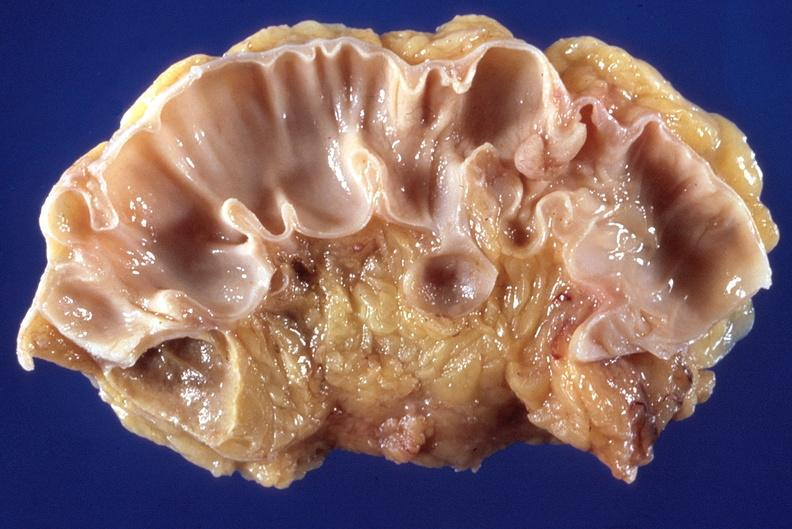s umbilical cord present?
Answer the question using a single word or phrase. No 